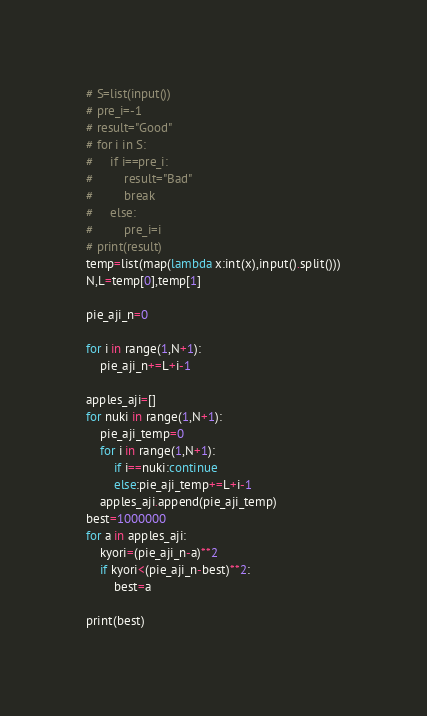<code> <loc_0><loc_0><loc_500><loc_500><_Python_># S=list(input())
# pre_i=-1
# result="Good"
# for i in S:
#     if i==pre_i:
#         result="Bad"
#         break
#     else:
#         pre_i=i
# print(result)
temp=list(map(lambda x:int(x),input().split()))
N,L=temp[0],temp[1]

pie_aji_n=0

for i in range(1,N+1):
    pie_aji_n+=L+i-1

apples_aji=[]
for nuki in range(1,N+1):
    pie_aji_temp=0
    for i in range(1,N+1):
        if i==nuki:continue
        else:pie_aji_temp+=L+i-1
    apples_aji.append(pie_aji_temp)
best=1000000
for a in apples_aji:
    kyori=(pie_aji_n-a)**2
    if kyori<(pie_aji_n-best)**2:
        best=a

print(best)
</code> 